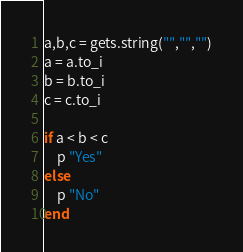<code> <loc_0><loc_0><loc_500><loc_500><_Ruby_>a,b,c = gets.string("","","")
a = a.to_i
b = b.to_i
c = c.to_i

if a < b < c
    p "Yes"
else
    p "No"
end
</code> 